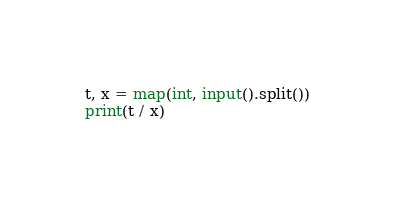<code> <loc_0><loc_0><loc_500><loc_500><_Python_>t, x = map(int, input().split())
print(t / x)
</code> 